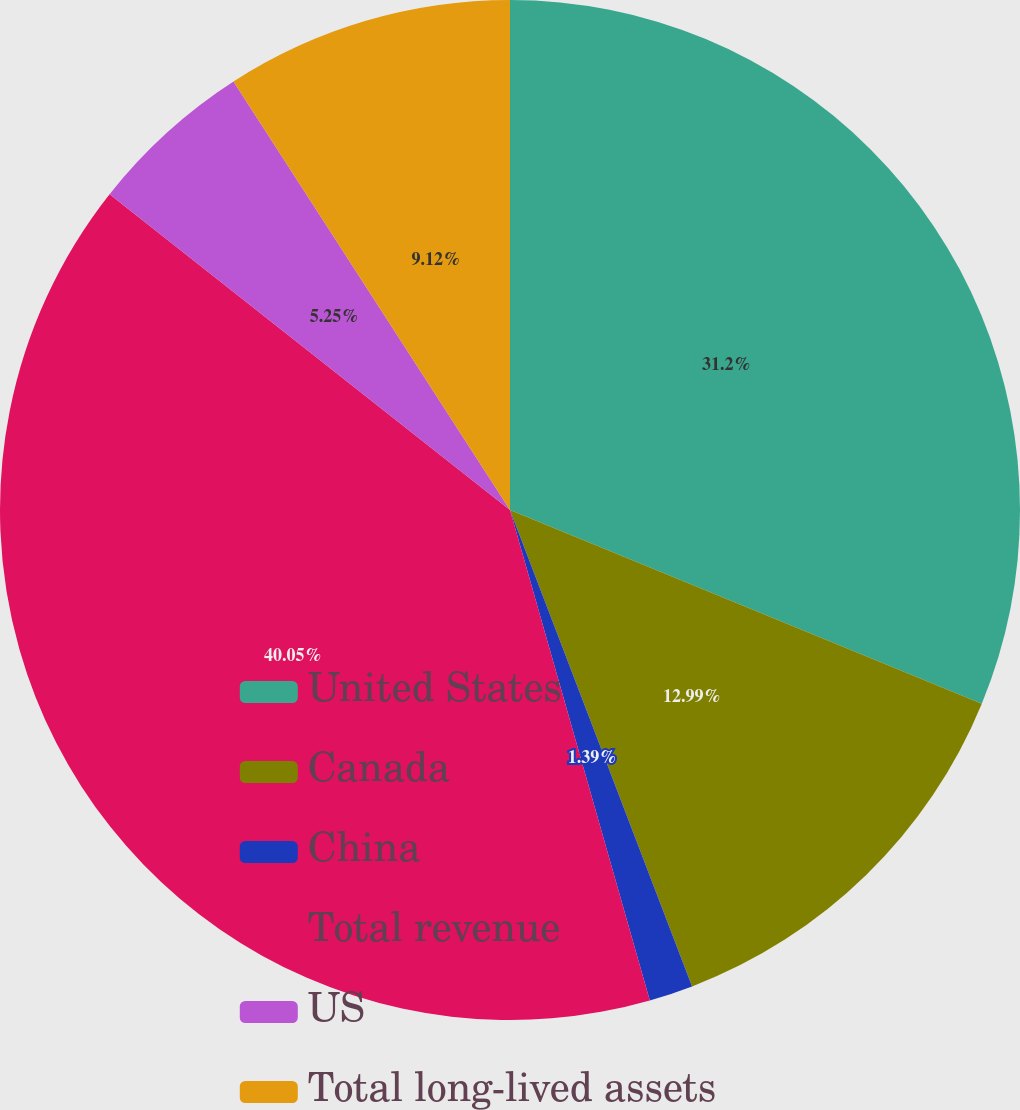Convert chart. <chart><loc_0><loc_0><loc_500><loc_500><pie_chart><fcel>United States<fcel>Canada<fcel>China<fcel>Total revenue<fcel>US<fcel>Total long-lived assets<nl><fcel>31.2%<fcel>12.99%<fcel>1.39%<fcel>40.05%<fcel>5.25%<fcel>9.12%<nl></chart> 